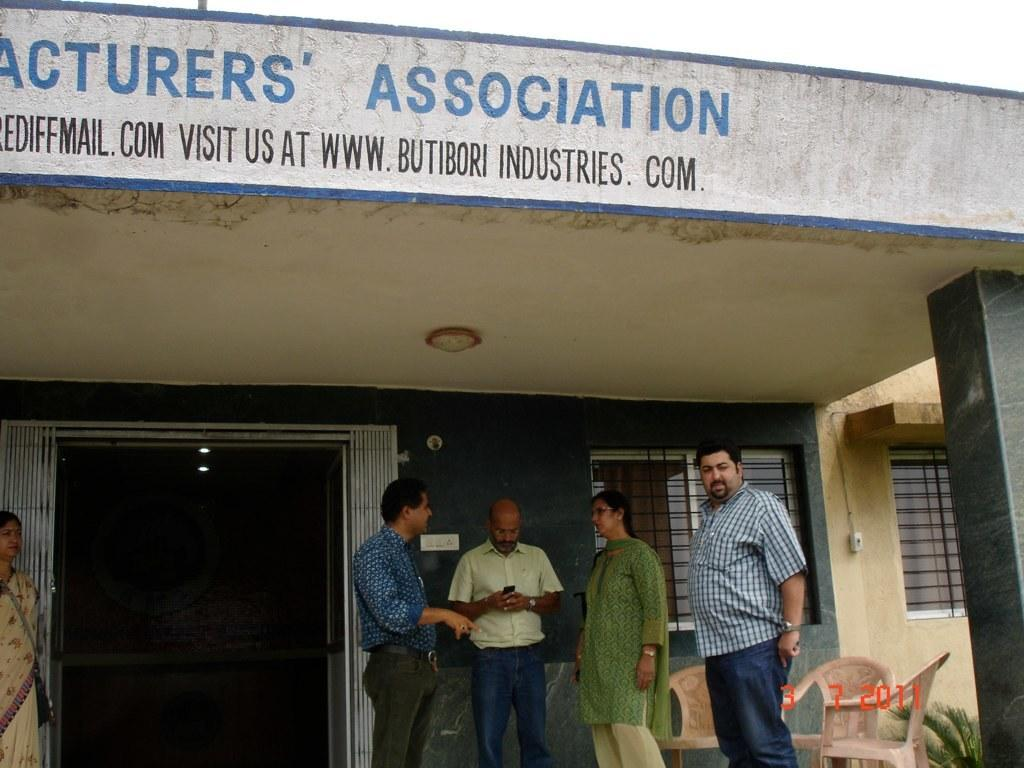What can be seen at the bottom of the image? There are people standing at the bottom of the image. What objects are located behind the people? There are chairs behind the people. What type of vegetation is visible behind the people and chairs? There are plants behind the people and chairs. What structure is in the middle of the image? There is a building in the middle of the image. What is visible at the top of the image? The sky is visible at the top of the image. What reason does the island have for being in the image? There is no island present in the image, so it cannot have a reason for being there. Can you describe the plane flying in the sky in the image? There is no plane visible in the sky in the image. 